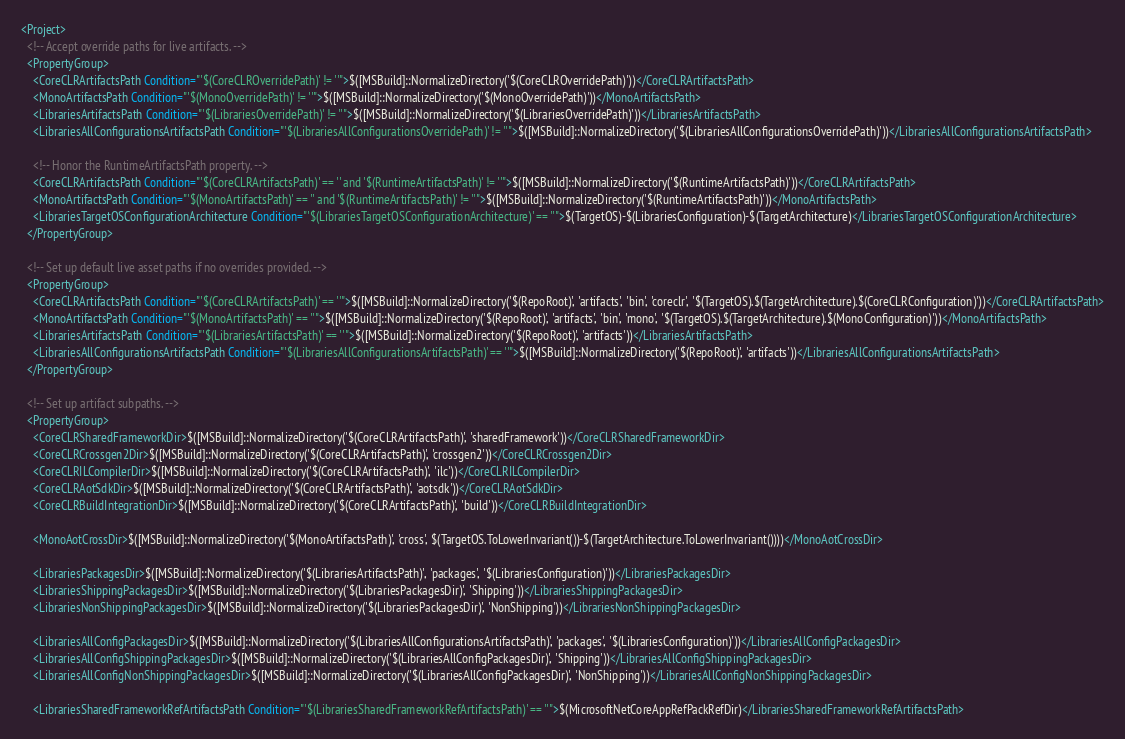<code> <loc_0><loc_0><loc_500><loc_500><_XML_><Project>
  <!-- Accept override paths for live artifacts. -->
  <PropertyGroup>
    <CoreCLRArtifactsPath Condition="'$(CoreCLROverridePath)' != ''">$([MSBuild]::NormalizeDirectory('$(CoreCLROverridePath)'))</CoreCLRArtifactsPath>
    <MonoArtifactsPath Condition="'$(MonoOverridePath)' != ''">$([MSBuild]::NormalizeDirectory('$(MonoOverridePath)'))</MonoArtifactsPath>
    <LibrariesArtifactsPath Condition="'$(LibrariesOverridePath)' != ''">$([MSBuild]::NormalizeDirectory('$(LibrariesOverridePath)'))</LibrariesArtifactsPath>
    <LibrariesAllConfigurationsArtifactsPath Condition="'$(LibrariesAllConfigurationsOverridePath)' != ''">$([MSBuild]::NormalizeDirectory('$(LibrariesAllConfigurationsOverridePath)'))</LibrariesAllConfigurationsArtifactsPath>

    <!-- Honor the RuntimeArtifactsPath property. -->
    <CoreCLRArtifactsPath Condition="'$(CoreCLRArtifactsPath)' == '' and '$(RuntimeArtifactsPath)' != ''">$([MSBuild]::NormalizeDirectory('$(RuntimeArtifactsPath)'))</CoreCLRArtifactsPath>
    <MonoArtifactsPath Condition="'$(MonoArtifactsPath)' == '' and '$(RuntimeArtifactsPath)' != ''">$([MSBuild]::NormalizeDirectory('$(RuntimeArtifactsPath)'))</MonoArtifactsPath>
    <LibrariesTargetOSConfigurationArchitecture Condition="'$(LibrariesTargetOSConfigurationArchitecture)' == ''">$(TargetOS)-$(LibrariesConfiguration)-$(TargetArchitecture)</LibrariesTargetOSConfigurationArchitecture>
  </PropertyGroup>

  <!-- Set up default live asset paths if no overrides provided. -->
  <PropertyGroup>
    <CoreCLRArtifactsPath Condition="'$(CoreCLRArtifactsPath)' == ''">$([MSBuild]::NormalizeDirectory('$(RepoRoot)', 'artifacts', 'bin', 'coreclr', '$(TargetOS).$(TargetArchitecture).$(CoreCLRConfiguration)'))</CoreCLRArtifactsPath>
    <MonoArtifactsPath Condition="'$(MonoArtifactsPath)' == ''">$([MSBuild]::NormalizeDirectory('$(RepoRoot)', 'artifacts', 'bin', 'mono', '$(TargetOS).$(TargetArchitecture).$(MonoConfiguration)'))</MonoArtifactsPath>
    <LibrariesArtifactsPath Condition="'$(LibrariesArtifactsPath)' == ''">$([MSBuild]::NormalizeDirectory('$(RepoRoot)', 'artifacts'))</LibrariesArtifactsPath>
    <LibrariesAllConfigurationsArtifactsPath Condition="'$(LibrariesAllConfigurationsArtifactsPath)' == ''">$([MSBuild]::NormalizeDirectory('$(RepoRoot)', 'artifacts'))</LibrariesAllConfigurationsArtifactsPath>
  </PropertyGroup>

  <!-- Set up artifact subpaths. -->
  <PropertyGroup>
    <CoreCLRSharedFrameworkDir>$([MSBuild]::NormalizeDirectory('$(CoreCLRArtifactsPath)', 'sharedFramework'))</CoreCLRSharedFrameworkDir>
    <CoreCLRCrossgen2Dir>$([MSBuild]::NormalizeDirectory('$(CoreCLRArtifactsPath)', 'crossgen2'))</CoreCLRCrossgen2Dir>
    <CoreCLRILCompilerDir>$([MSBuild]::NormalizeDirectory('$(CoreCLRArtifactsPath)', 'ilc'))</CoreCLRILCompilerDir>
    <CoreCLRAotSdkDir>$([MSBuild]::NormalizeDirectory('$(CoreCLRArtifactsPath)', 'aotsdk'))</CoreCLRAotSdkDir>
    <CoreCLRBuildIntegrationDir>$([MSBuild]::NormalizeDirectory('$(CoreCLRArtifactsPath)', 'build'))</CoreCLRBuildIntegrationDir>

    <MonoAotCrossDir>$([MSBuild]::NormalizeDirectory('$(MonoArtifactsPath)', 'cross', $(TargetOS.ToLowerInvariant())-$(TargetArchitecture.ToLowerInvariant())))</MonoAotCrossDir>

    <LibrariesPackagesDir>$([MSBuild]::NormalizeDirectory('$(LibrariesArtifactsPath)', 'packages', '$(LibrariesConfiguration)'))</LibrariesPackagesDir>
    <LibrariesShippingPackagesDir>$([MSBuild]::NormalizeDirectory('$(LibrariesPackagesDir)', 'Shipping'))</LibrariesShippingPackagesDir>
    <LibrariesNonShippingPackagesDir>$([MSBuild]::NormalizeDirectory('$(LibrariesPackagesDir)', 'NonShipping'))</LibrariesNonShippingPackagesDir>

    <LibrariesAllConfigPackagesDir>$([MSBuild]::NormalizeDirectory('$(LibrariesAllConfigurationsArtifactsPath)', 'packages', '$(LibrariesConfiguration)'))</LibrariesAllConfigPackagesDir>
    <LibrariesAllConfigShippingPackagesDir>$([MSBuild]::NormalizeDirectory('$(LibrariesAllConfigPackagesDir)', 'Shipping'))</LibrariesAllConfigShippingPackagesDir>
    <LibrariesAllConfigNonShippingPackagesDir>$([MSBuild]::NormalizeDirectory('$(LibrariesAllConfigPackagesDir)', 'NonShipping'))</LibrariesAllConfigNonShippingPackagesDir>

    <LibrariesSharedFrameworkRefArtifactsPath Condition="'$(LibrariesSharedFrameworkRefArtifactsPath)' == ''">$(MicrosoftNetCoreAppRefPackRefDir)</LibrariesSharedFrameworkRefArtifactsPath></code> 